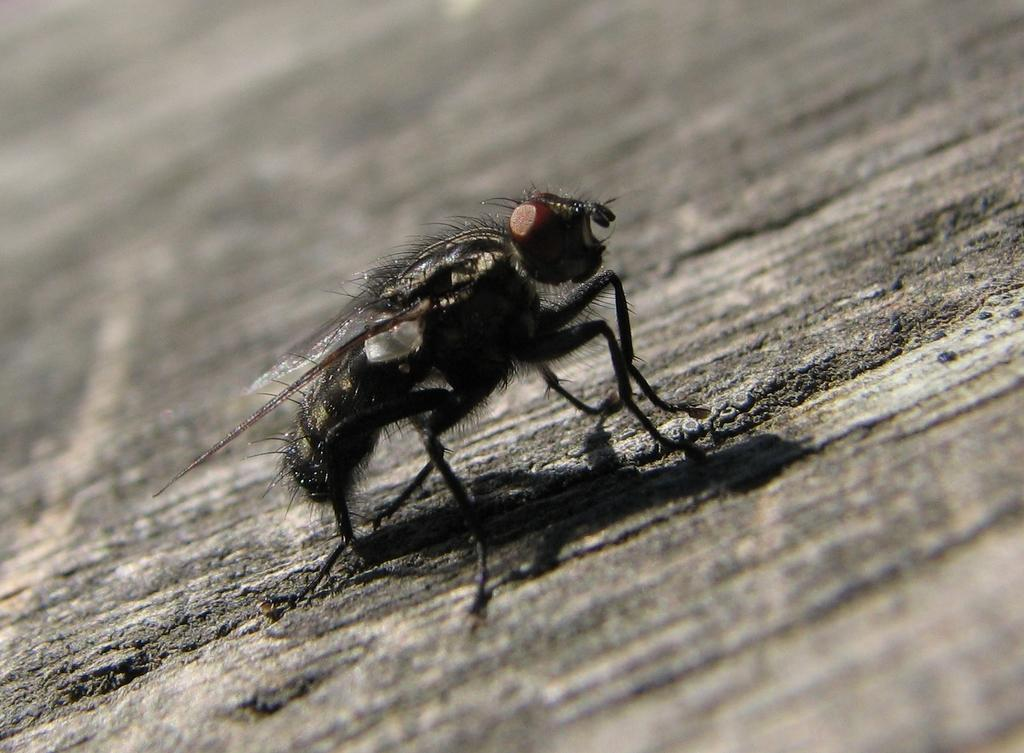What type of insect is present in the image? There is a black color insect in the image. What type of key is being used to teach the insect in the image? There is no key or teaching activity present in the image; it only features a black color insect. 